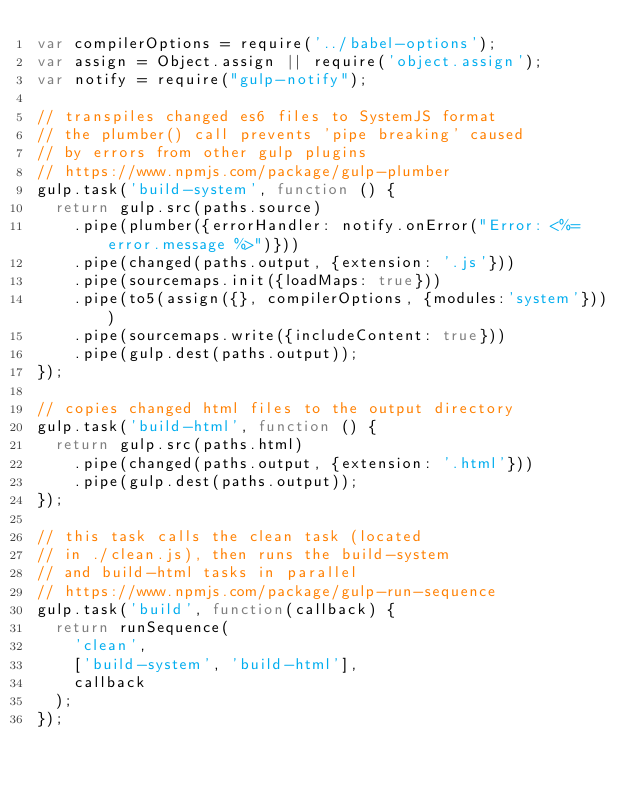<code> <loc_0><loc_0><loc_500><loc_500><_JavaScript_>var compilerOptions = require('../babel-options');
var assign = Object.assign || require('object.assign');
var notify = require("gulp-notify");

// transpiles changed es6 files to SystemJS format
// the plumber() call prevents 'pipe breaking' caused
// by errors from other gulp plugins
// https://www.npmjs.com/package/gulp-plumber
gulp.task('build-system', function () {
  return gulp.src(paths.source)
    .pipe(plumber({errorHandler: notify.onError("Error: <%= error.message %>")}))
    .pipe(changed(paths.output, {extension: '.js'}))
    .pipe(sourcemaps.init({loadMaps: true}))
    .pipe(to5(assign({}, compilerOptions, {modules:'system'})))
    .pipe(sourcemaps.write({includeContent: true}))
    .pipe(gulp.dest(paths.output));
});

// copies changed html files to the output directory
gulp.task('build-html', function () {
  return gulp.src(paths.html)
    .pipe(changed(paths.output, {extension: '.html'}))
    .pipe(gulp.dest(paths.output));
});

// this task calls the clean task (located
// in ./clean.js), then runs the build-system
// and build-html tasks in parallel
// https://www.npmjs.com/package/gulp-run-sequence
gulp.task('build', function(callback) {
  return runSequence(
    'clean',
    ['build-system', 'build-html'],
    callback
  );
});
</code> 